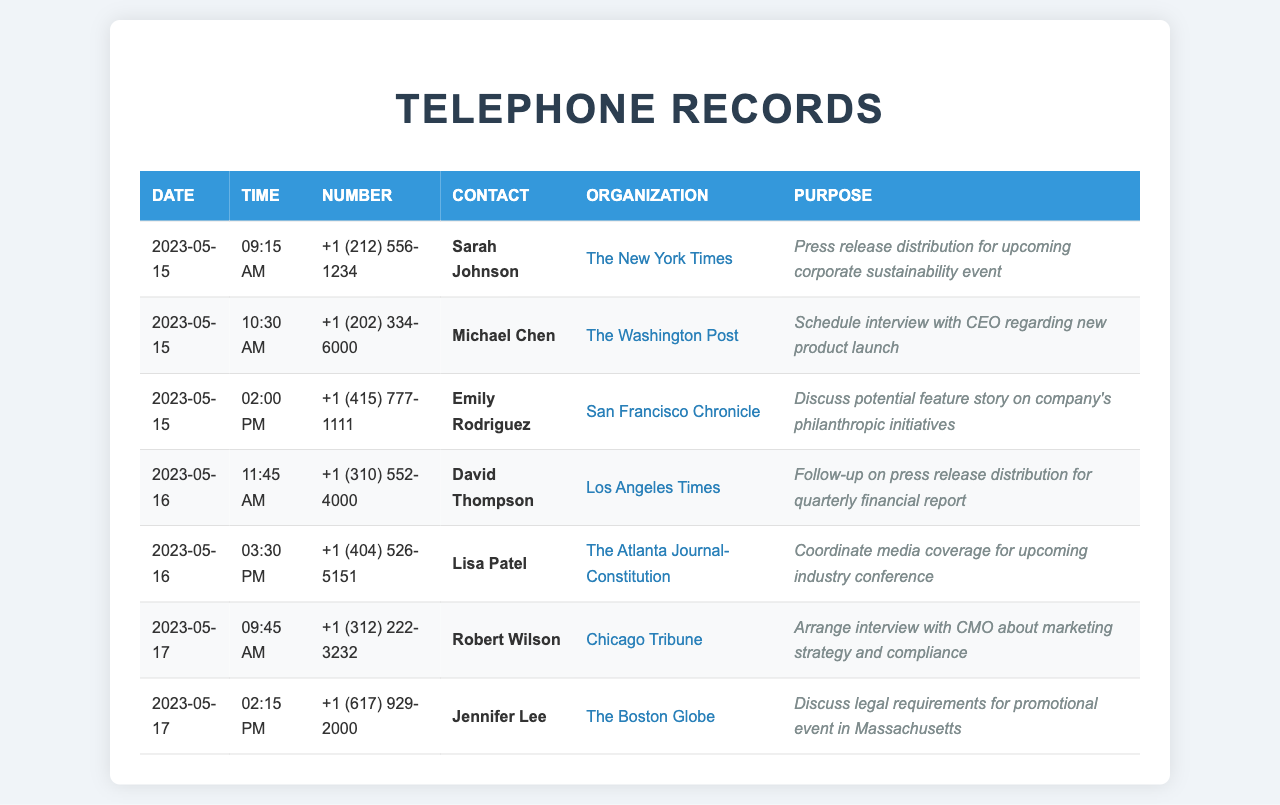What is the date of the first call? The first call listed was made on May 15, 2023.
Answer: May 15, 2023 Who is the contact for the call to The Washington Post? The contact person for The Washington Post is Michael Chen.
Answer: Michael Chen What time was the call to schedule the interview with the CEO? The call to schedule the interview with the CEO took place at 10:30 AM.
Answer: 10:30 AM Which organization did David Thompson represent? David Thompson was with the Los Angeles Times.
Answer: Los Angeles Times How many calls were made on May 16, 2023? There were two calls made on May 16, 2023, as indicated in the document.
Answer: 2 What was the purpose of the call to The Boston Globe? The call to The Boston Globe was to discuss legal requirements for promotional event in Massachusetts.
Answer: Discuss legal requirements for promotional event in Massachusetts What is the phone number for Sarah Johnson? Sarah Johnson's phone number is +1 (212) 556-1234.
Answer: +1 (212) 556-1234 Which media outlet is associated with Emily Rodriguez? Emily Rodriguez is associated with the San Francisco Chronicle.
Answer: San Francisco Chronicle What was the main focus of the call to coordinate media coverage? The call focused on coordinating media coverage for an upcoming industry conference.
Answer: Coordinate media coverage for upcoming industry conference 